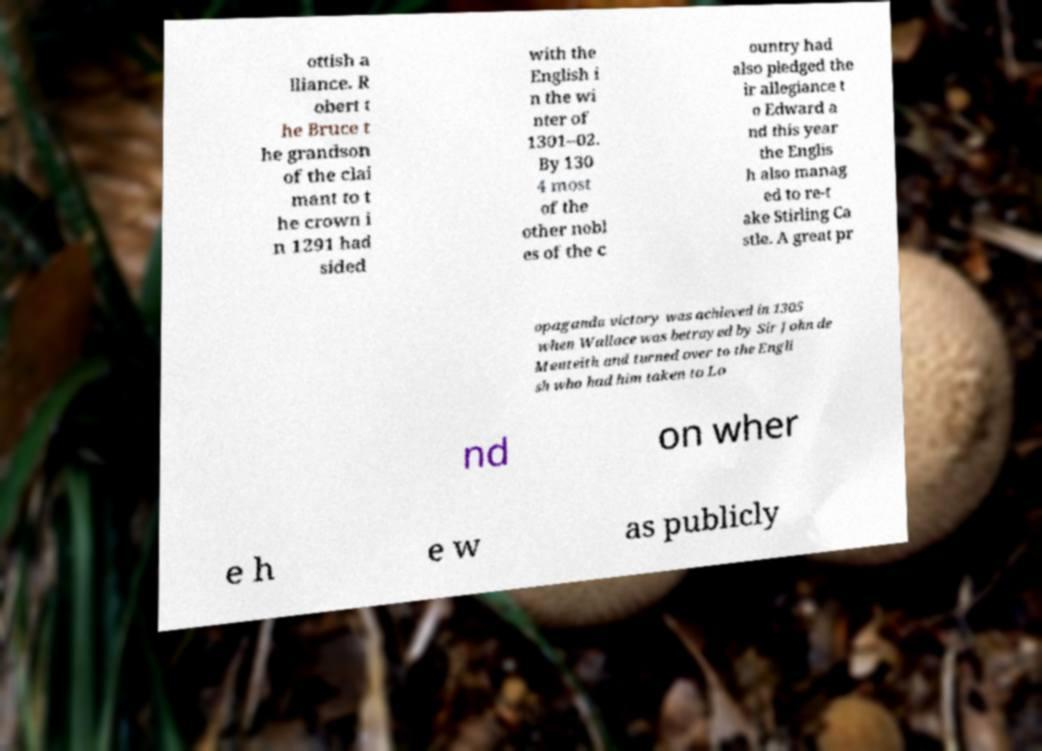Could you extract and type out the text from this image? ottish a lliance. R obert t he Bruce t he grandson of the clai mant to t he crown i n 1291 had sided with the English i n the wi nter of 1301–02. By 130 4 most of the other nobl es of the c ountry had also pledged the ir allegiance t o Edward a nd this year the Englis h also manag ed to re-t ake Stirling Ca stle. A great pr opaganda victory was achieved in 1305 when Wallace was betrayed by Sir John de Menteith and turned over to the Engli sh who had him taken to Lo nd on wher e h e w as publicly 